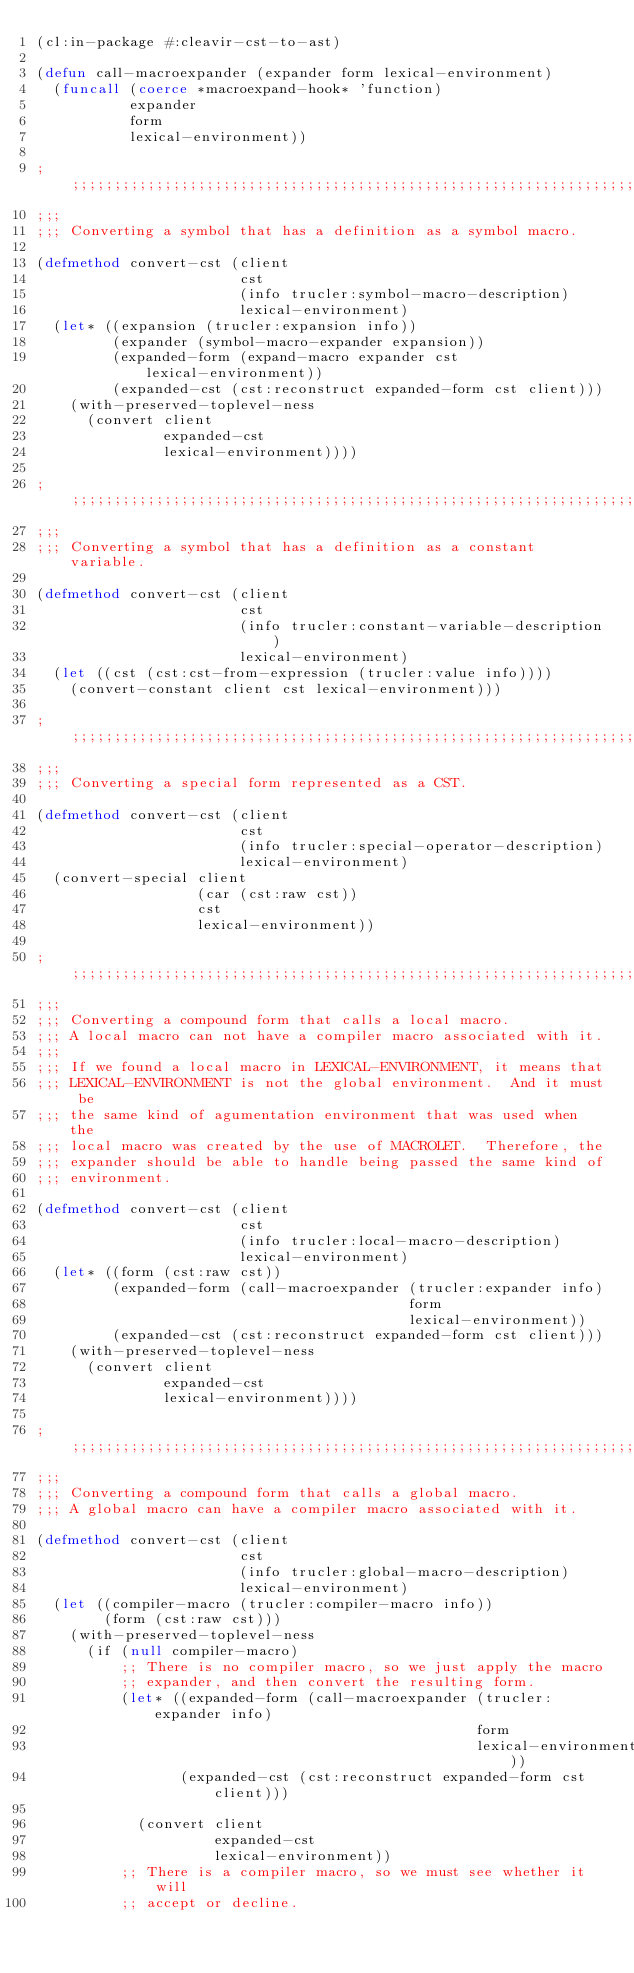Convert code to text. <code><loc_0><loc_0><loc_500><loc_500><_Lisp_>(cl:in-package #:cleavir-cst-to-ast)

(defun call-macroexpander (expander form lexical-environment)
  (funcall (coerce *macroexpand-hook* 'function)
           expander
           form
           lexical-environment))

;;;;;;;;;;;;;;;;;;;;;;;;;;;;;;;;;;;;;;;;;;;;;;;;;;;;;;;;;;;;;;;;;;;;;;
;;;
;;; Converting a symbol that has a definition as a symbol macro.

(defmethod convert-cst (client
                        cst
                        (info trucler:symbol-macro-description)
                        lexical-environment)
  (let* ((expansion (trucler:expansion info))
         (expander (symbol-macro-expander expansion))
         (expanded-form (expand-macro expander cst lexical-environment))
         (expanded-cst (cst:reconstruct expanded-form cst client)))
    (with-preserved-toplevel-ness
      (convert client
               expanded-cst
               lexical-environment))))

;;;;;;;;;;;;;;;;;;;;;;;;;;;;;;;;;;;;;;;;;;;;;;;;;;;;;;;;;;;;;;;;;;;;;;
;;;
;;; Converting a symbol that has a definition as a constant variable.

(defmethod convert-cst (client
                        cst
                        (info trucler:constant-variable-description)
                        lexical-environment)
  (let ((cst (cst:cst-from-expression (trucler:value info))))
    (convert-constant client cst lexical-environment)))

;;;;;;;;;;;;;;;;;;;;;;;;;;;;;;;;;;;;;;;;;;;;;;;;;;;;;;;;;;;;;;;;;;;;;;
;;;
;;; Converting a special form represented as a CST.

(defmethod convert-cst (client
                        cst
                        (info trucler:special-operator-description)
                        lexical-environment)
  (convert-special client
                   (car (cst:raw cst))
                   cst
                   lexical-environment))

;;;;;;;;;;;;;;;;;;;;;;;;;;;;;;;;;;;;;;;;;;;;;;;;;;;;;;;;;;;;;;;;;;;;;;
;;;
;;; Converting a compound form that calls a local macro.
;;; A local macro can not have a compiler macro associated with it.
;;;
;;; If we found a local macro in LEXICAL-ENVIRONMENT, it means that
;;; LEXICAL-ENVIRONMENT is not the global environment.  And it must be
;;; the same kind of agumentation environment that was used when the
;;; local macro was created by the use of MACROLET.  Therefore, the
;;; expander should be able to handle being passed the same kind of
;;; environment.

(defmethod convert-cst (client
                        cst
                        (info trucler:local-macro-description)
                        lexical-environment)
  (let* ((form (cst:raw cst))
         (expanded-form (call-macroexpander (trucler:expander info)
                                            form
                                            lexical-environment))
         (expanded-cst (cst:reconstruct expanded-form cst client)))
    (with-preserved-toplevel-ness
      (convert client
               expanded-cst
               lexical-environment))))

;;;;;;;;;;;;;;;;;;;;;;;;;;;;;;;;;;;;;;;;;;;;;;;;;;;;;;;;;;;;;;;;;;;;;;
;;;
;;; Converting a compound form that calls a global macro.
;;; A global macro can have a compiler macro associated with it.

(defmethod convert-cst (client
                        cst
                        (info trucler:global-macro-description)
                        lexical-environment)
  (let ((compiler-macro (trucler:compiler-macro info))
        (form (cst:raw cst)))
    (with-preserved-toplevel-ness
      (if (null compiler-macro)
          ;; There is no compiler macro, so we just apply the macro
          ;; expander, and then convert the resulting form.
          (let* ((expanded-form (call-macroexpander (trucler:expander info)
                                                    form
                                                    lexical-environment))
                 (expanded-cst (cst:reconstruct expanded-form cst client)))

            (convert client
                     expanded-cst
                     lexical-environment))
          ;; There is a compiler macro, so we must see whether it will
          ;; accept or decline.</code> 